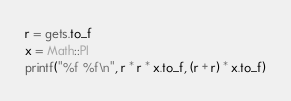Convert code to text. <code><loc_0><loc_0><loc_500><loc_500><_Ruby_>r = gets.to_f
x = Math::PI
printf("%f %f\n", r * r * x.to_f, (r + r) * x.to_f)</code> 